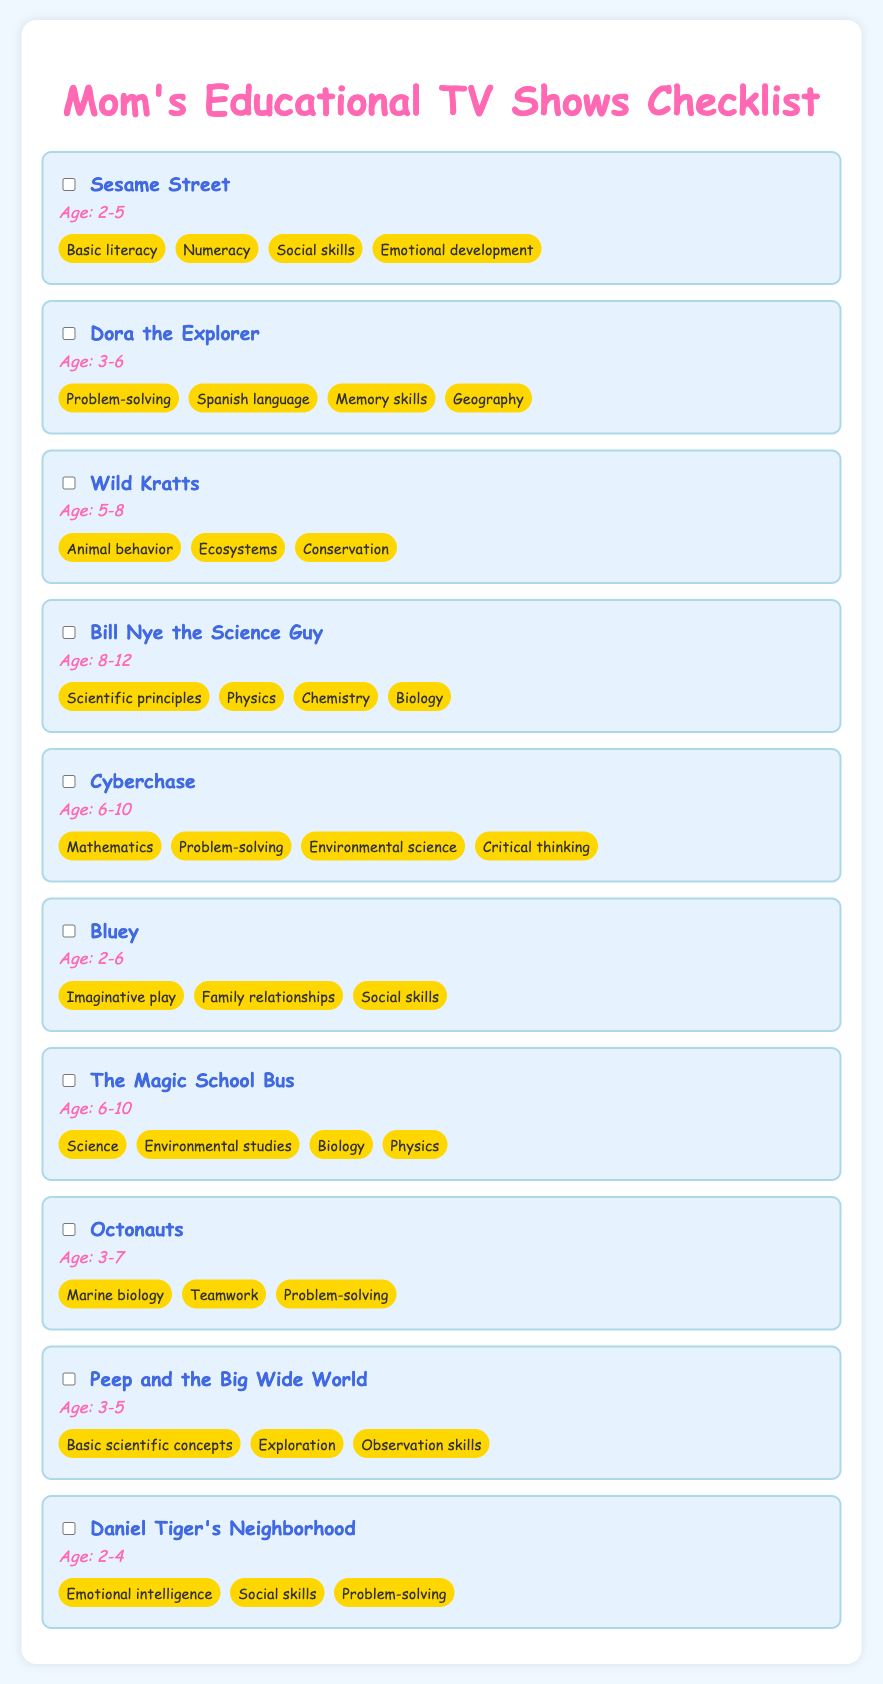What is the age recommendation for Sesame Street? The age recommendation for Sesame Street is specified in the document and is listed as Age: 2-5.
Answer: Age: 2-5 Which show focuses on animal behavior? The learning focus for Wild Kratts includes animal behavior, as stated within its details in the document.
Answer: Animal behavior How many shows are recommended for ages 6-10? By counting the shows listed with age recommendations targeting ages 6-10, there are two shows: Cyberchase and The Magic School Bus.
Answer: 2 What learning focus does Bluey have? Bluey has multiple learning focuses including imaginative play, family relationships, and social skills as mentioned in the document.
Answer: Imaginative play, family relationships, social skills What is the age recommendation for Daniel Tiger's Neighborhood? The document specifies the age recommendation for Daniel Tiger's Neighborhood as Age: 2-4.
Answer: Age: 2-4 Which show teaches Spanish language skills? Dora the Explorer is the show that includes Spanish language skills among its learning focuses as stated in the document.
Answer: Dora the Explorer How many educational TV shows are listed in total? The total number of educational TV shows mentioned in the document is counted to be ten.
Answer: 10 What are the main scientific subjects covered by Bill Nye the Science Guy? The main scientific subjects are listed as scientific principles, physics, chemistry, and biology for Bill Nye the Science Guy.
Answer: Scientific principles, physics, chemistry, biology What is the learning focus of Peep and the Big Wide World? The learning focus for Peep and the Big Wide World includes basic scientific concepts, exploration, and observation skills according to the document.
Answer: Basic scientific concepts, exploration, observation skills 